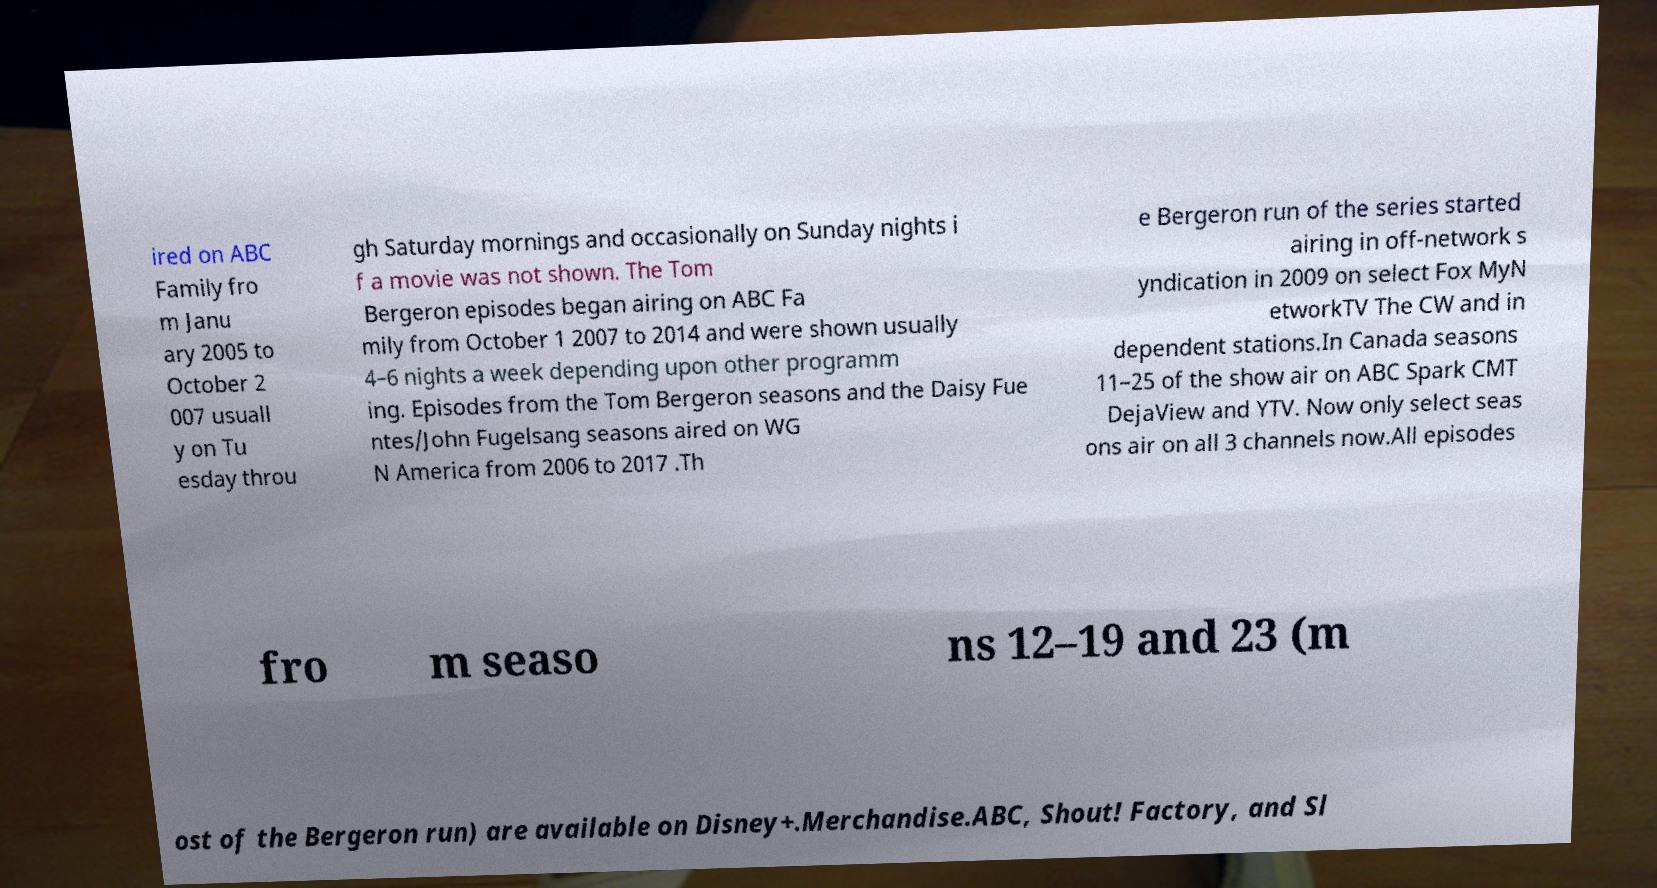Please read and relay the text visible in this image. What does it say? ired on ABC Family fro m Janu ary 2005 to October 2 007 usuall y on Tu esday throu gh Saturday mornings and occasionally on Sunday nights i f a movie was not shown. The Tom Bergeron episodes began airing on ABC Fa mily from October 1 2007 to 2014 and were shown usually 4–6 nights a week depending upon other programm ing. Episodes from the Tom Bergeron seasons and the Daisy Fue ntes/John Fugelsang seasons aired on WG N America from 2006 to 2017 .Th e Bergeron run of the series started airing in off-network s yndication in 2009 on select Fox MyN etworkTV The CW and in dependent stations.In Canada seasons 11–25 of the show air on ABC Spark CMT DejaView and YTV. Now only select seas ons air on all 3 channels now.All episodes fro m seaso ns 12–19 and 23 (m ost of the Bergeron run) are available on Disney+.Merchandise.ABC, Shout! Factory, and Sl 